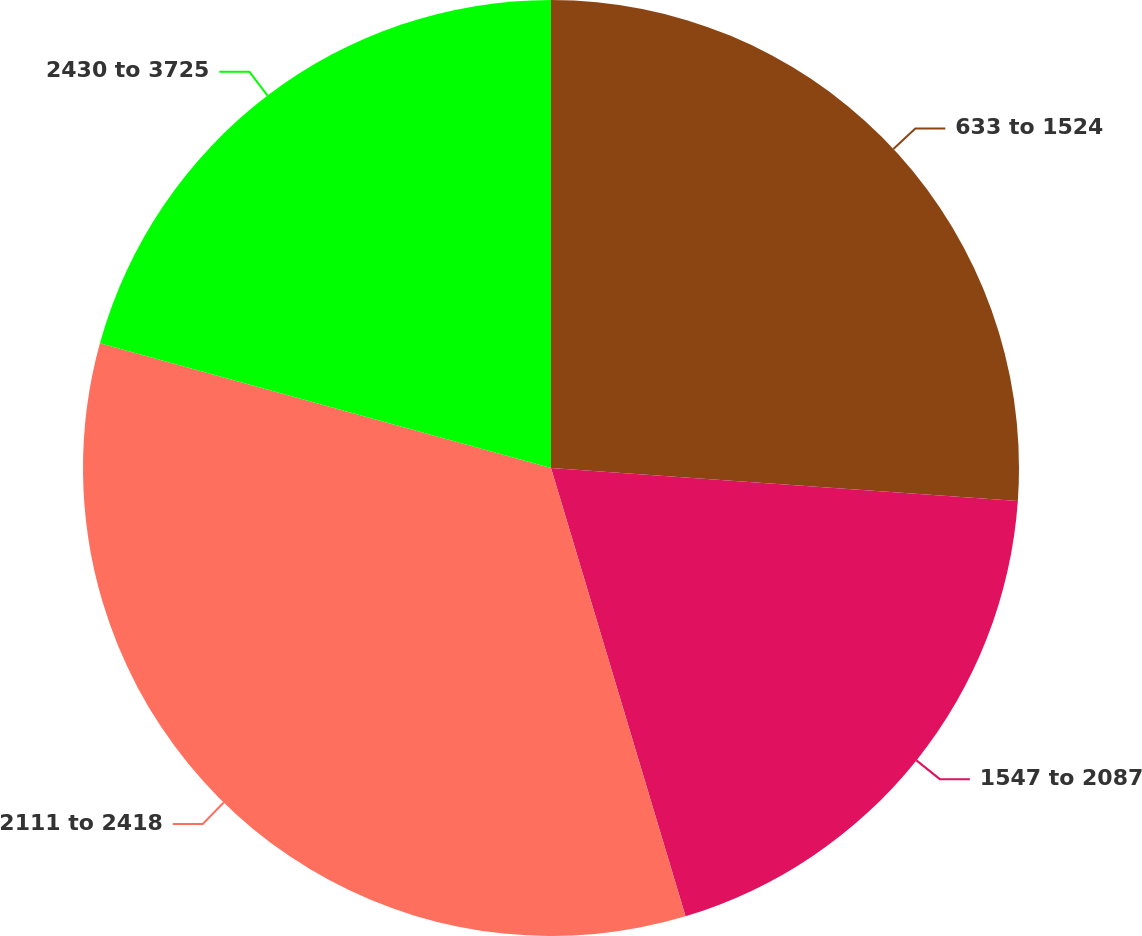<chart> <loc_0><loc_0><loc_500><loc_500><pie_chart><fcel>633 to 1524<fcel>1547 to 2087<fcel>2111 to 2418<fcel>2430 to 3725<nl><fcel>26.12%<fcel>19.24%<fcel>33.93%<fcel>20.71%<nl></chart> 